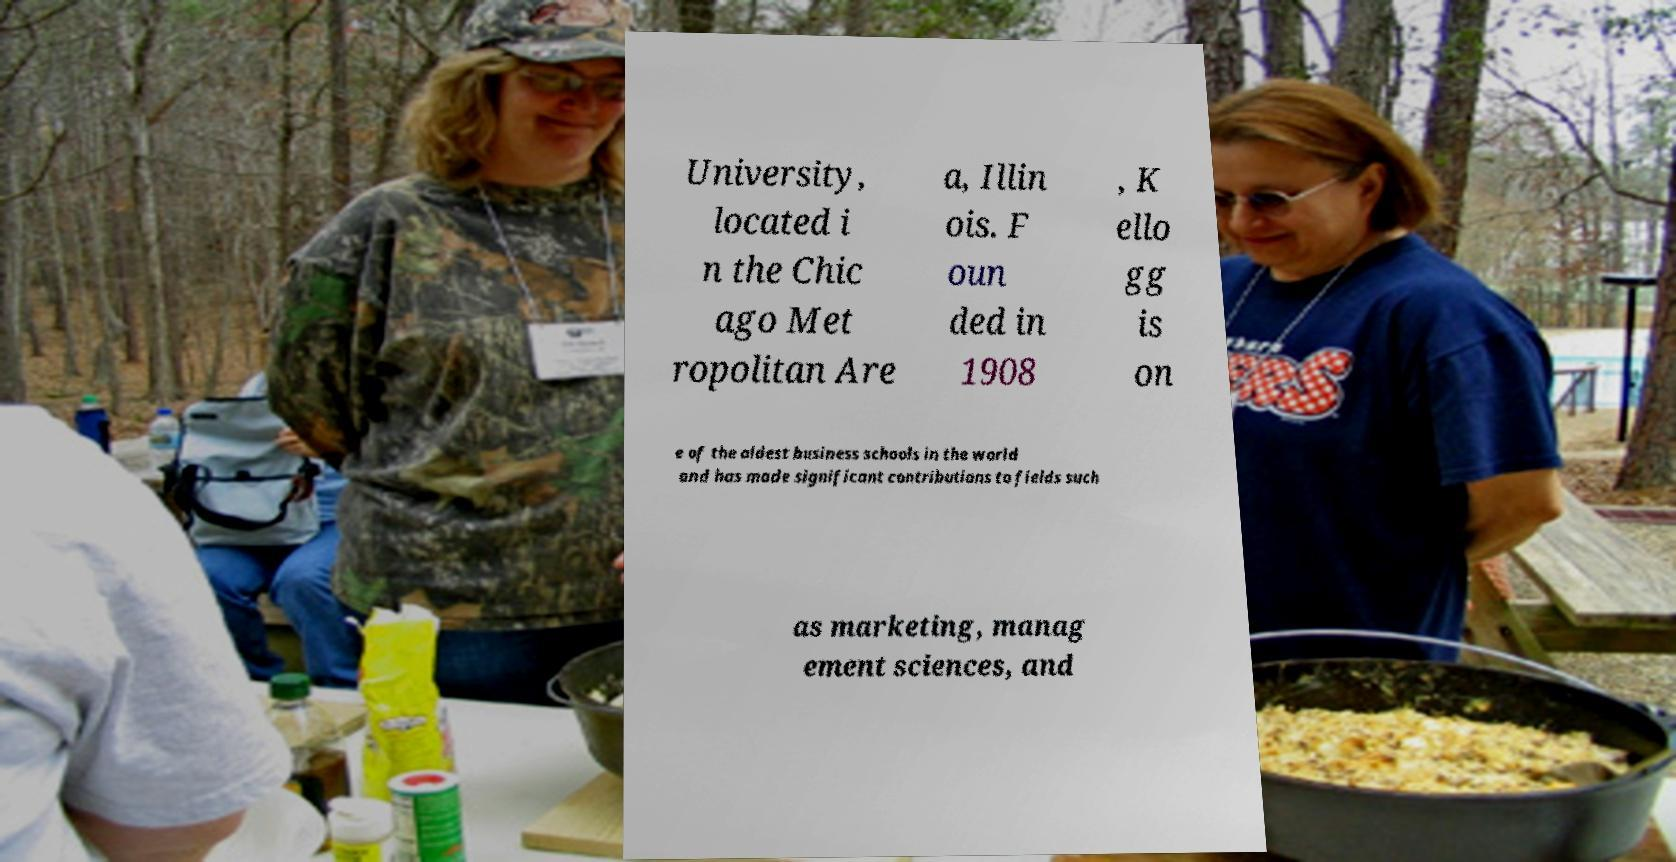There's text embedded in this image that I need extracted. Can you transcribe it verbatim? University, located i n the Chic ago Met ropolitan Are a, Illin ois. F oun ded in 1908 , K ello gg is on e of the oldest business schools in the world and has made significant contributions to fields such as marketing, manag ement sciences, and 